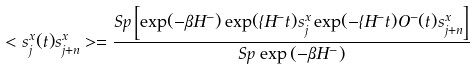<formula> <loc_0><loc_0><loc_500><loc_500>< s ^ { x } _ { j } ( t ) s ^ { x } _ { j + n } > = \frac { S p \left [ \exp ( - \beta H ^ { - } ) \exp ( \imath H ^ { - } t ) s ^ { x } _ { j } \exp ( - \imath H ^ { - } t ) O ^ { - } ( t ) s ^ { x } _ { j + n } \right ] } { S p \, \exp \left ( - \beta H ^ { - } \right ) }</formula> 